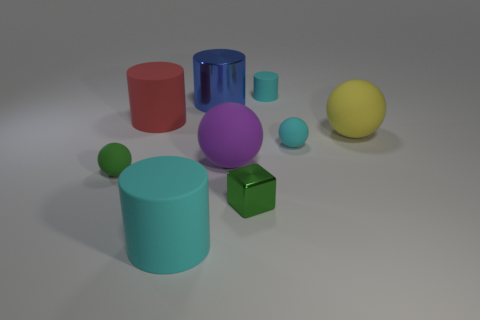Add 1 tiny spheres. How many objects exist? 10 Subtract all cyan rubber balls. How many balls are left? 3 Subtract 1 spheres. How many spheres are left? 3 Subtract all balls. How many objects are left? 5 Subtract all gray cylinders. Subtract all green cubes. How many cylinders are left? 4 Subtract all purple cylinders. How many yellow cubes are left? 0 Subtract all large blue rubber balls. Subtract all green blocks. How many objects are left? 8 Add 8 tiny rubber cylinders. How many tiny rubber cylinders are left? 9 Add 5 small cyan rubber objects. How many small cyan rubber objects exist? 7 Subtract all green balls. How many balls are left? 3 